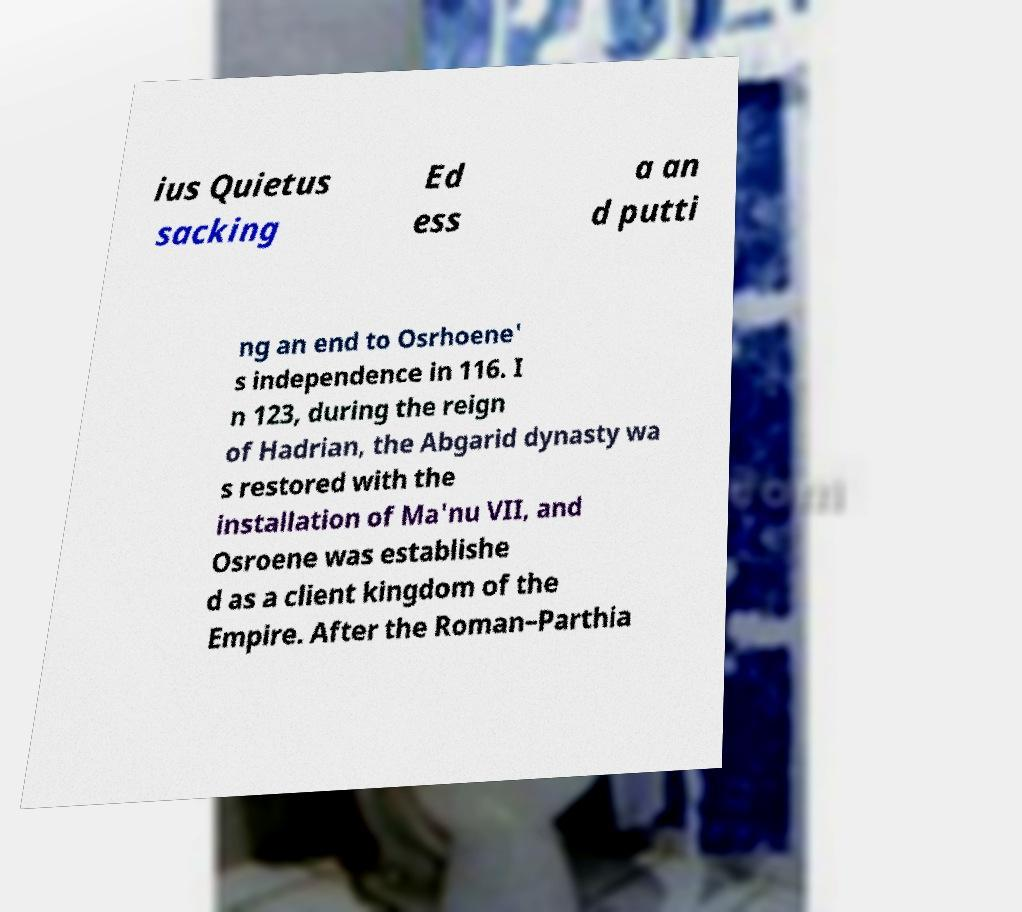Please read and relay the text visible in this image. What does it say? ius Quietus sacking Ed ess a an d putti ng an end to Osrhoene' s independence in 116. I n 123, during the reign of Hadrian, the Abgarid dynasty wa s restored with the installation of Ma'nu VII, and Osroene was establishe d as a client kingdom of the Empire. After the Roman–Parthia 